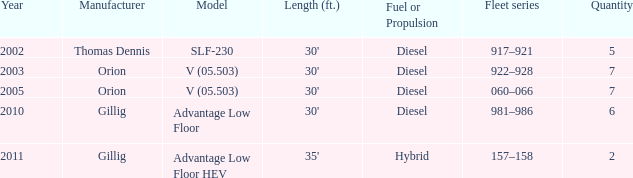Inform me of the model with diesel fuel or propulsion from the orion manufacturer in 200 V (05.503). 